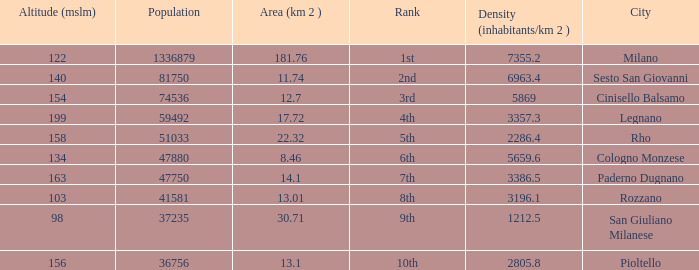Which Population is the highest one that has a Density (inhabitants/km 2) larger than 2805.8, and a Rank of 1st, and an Altitude (mslm) smaller than 122? None. 